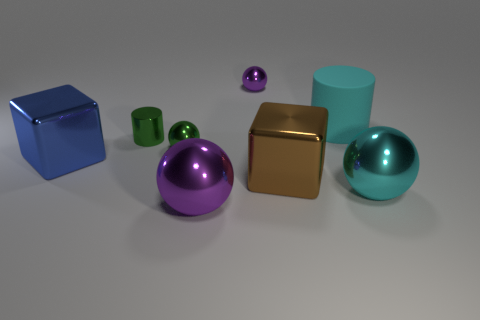Subtract 1 spheres. How many spheres are left? 3 Subtract all cylinders. How many objects are left? 6 Add 1 big spheres. How many objects exist? 9 Subtract all small green blocks. Subtract all small green cylinders. How many objects are left? 7 Add 5 big purple metallic balls. How many big purple metallic balls are left? 6 Add 2 cyan objects. How many cyan objects exist? 4 Subtract 0 purple cubes. How many objects are left? 8 